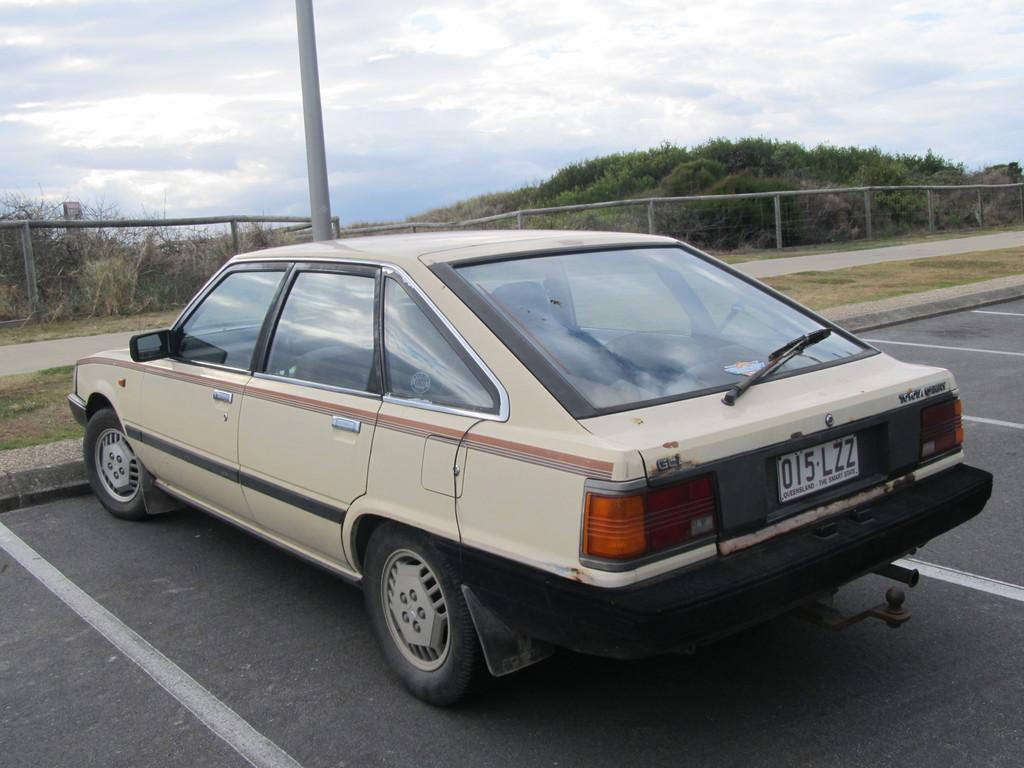Please provide a concise description of this image. In this image we can see a car on the road, in the background there is an iron pole, fence, trees and the sky. 